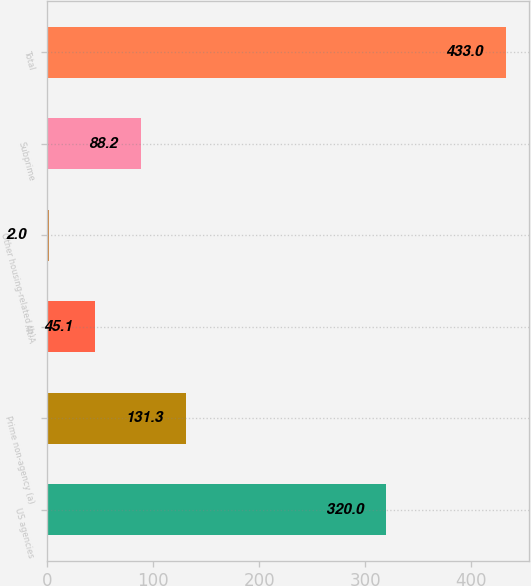<chart> <loc_0><loc_0><loc_500><loc_500><bar_chart><fcel>US agencies<fcel>Prime non-agency (a)<fcel>Alt-A<fcel>Other housing-related (b)<fcel>Subprime<fcel>Total<nl><fcel>320<fcel>131.3<fcel>45.1<fcel>2<fcel>88.2<fcel>433<nl></chart> 